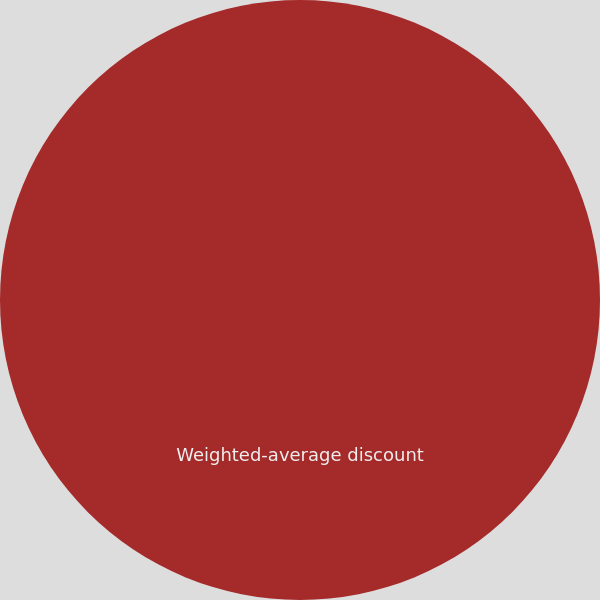Convert chart to OTSL. <chart><loc_0><loc_0><loc_500><loc_500><pie_chart><fcel>Weighted-average discount<nl><fcel>100.0%<nl></chart> 